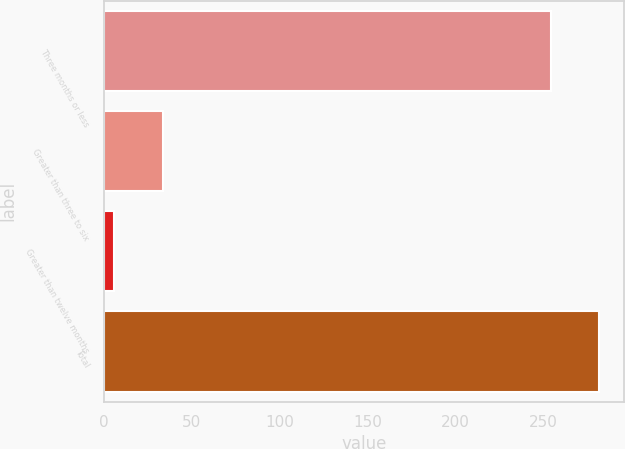Convert chart. <chart><loc_0><loc_0><loc_500><loc_500><bar_chart><fcel>Three months or less<fcel>Greater than three to six<fcel>Greater than twelve months<fcel>Total<nl><fcel>254<fcel>33.5<fcel>6<fcel>281.5<nl></chart> 